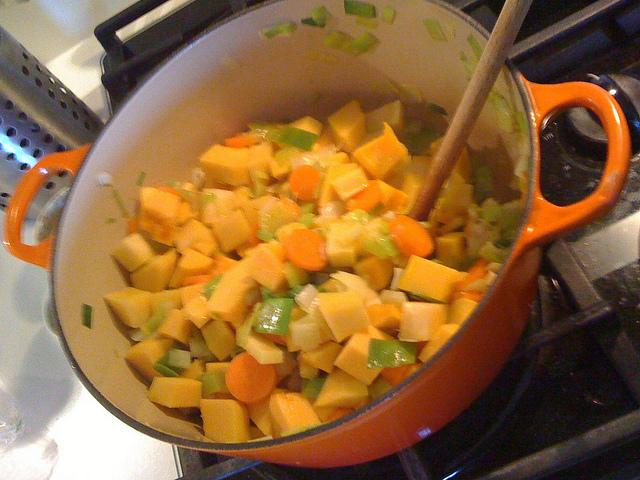What food's are shown?
Short answer required. Vegetables. Does it look like carrots inside the pot?
Keep it brief. Yes. What is the spoon made of?
Give a very brief answer. Wood. Is there anyone in the photo?
Be succinct. No. Is something cooking?
Keep it brief. Yes. 